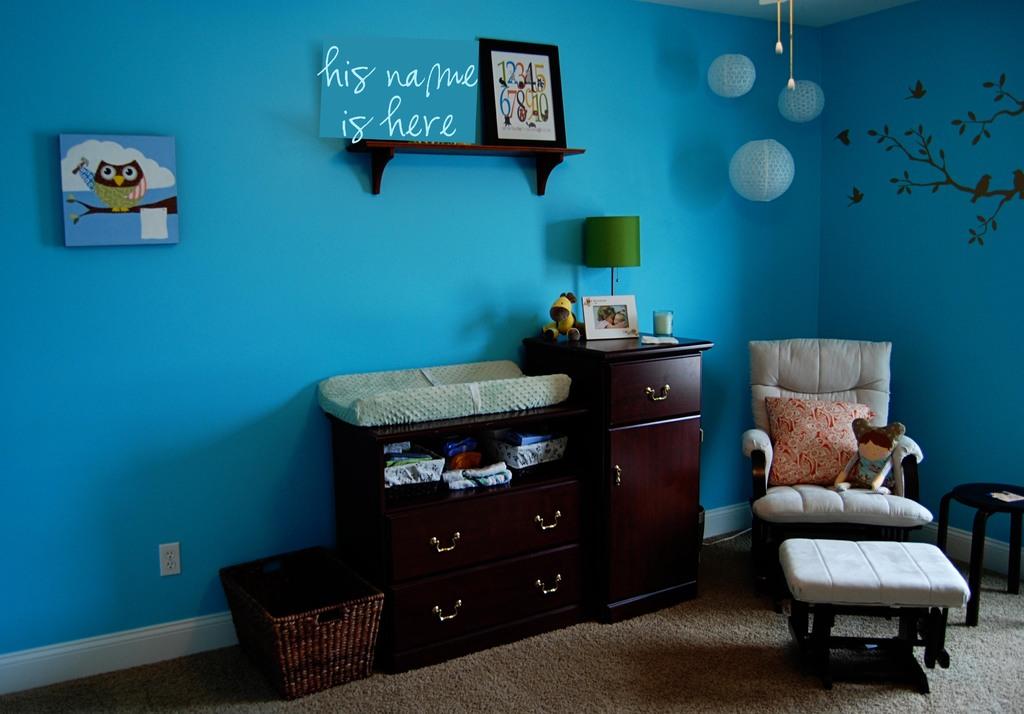Which baby gender is appropriate for this room?
Give a very brief answer. Answering does not require reading text in the image. His names goes wear?
Give a very brief answer. Here. 